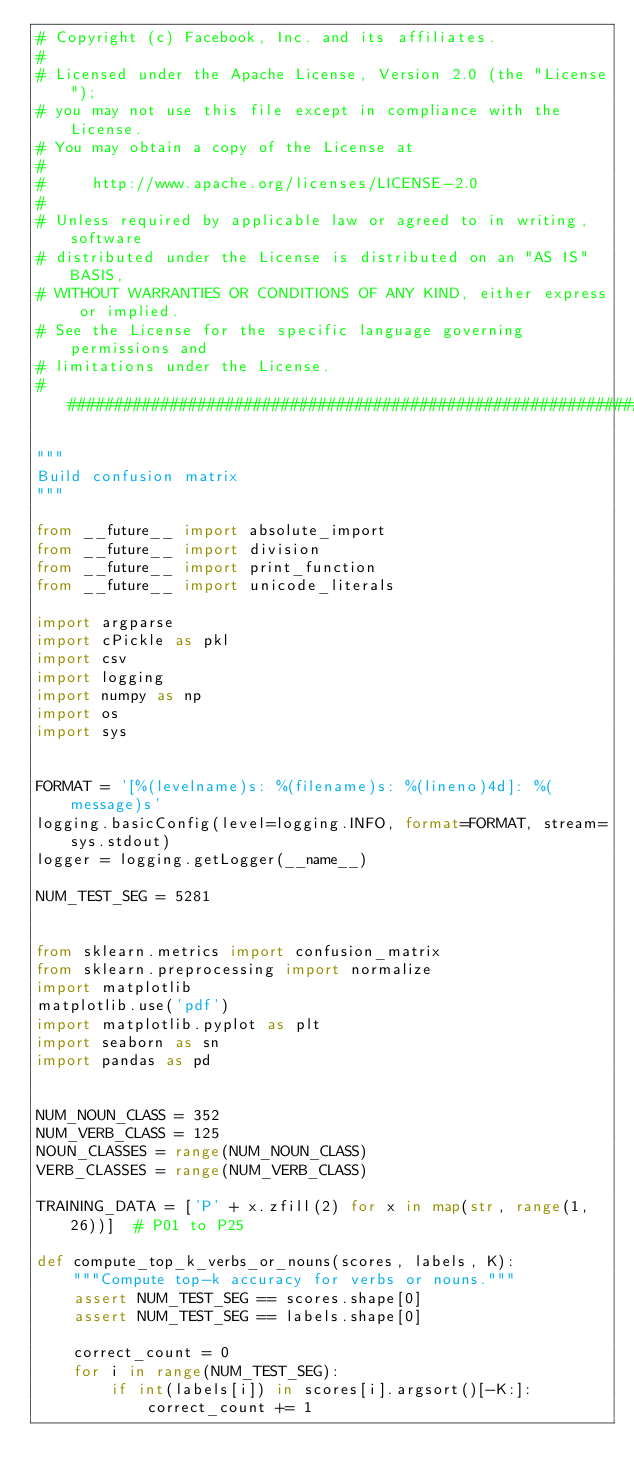<code> <loc_0><loc_0><loc_500><loc_500><_Python_># Copyright (c) Facebook, Inc. and its affiliates.
#
# Licensed under the Apache License, Version 2.0 (the "License");
# you may not use this file except in compliance with the License.
# You may obtain a copy of the License at
#
#     http://www.apache.org/licenses/LICENSE-2.0
#
# Unless required by applicable law or agreed to in writing, software
# distributed under the License is distributed on an "AS IS" BASIS,
# WITHOUT WARRANTIES OR CONDITIONS OF ANY KIND, either express or implied.
# See the License for the specific language governing permissions and
# limitations under the License.
##############################################################################

"""
Build confusion matrix
"""

from __future__ import absolute_import
from __future__ import division
from __future__ import print_function
from __future__ import unicode_literals

import argparse
import cPickle as pkl
import csv
import logging
import numpy as np
import os
import sys


FORMAT = '[%(levelname)s: %(filename)s: %(lineno)4d]: %(message)s'
logging.basicConfig(level=logging.INFO, format=FORMAT, stream=sys.stdout)
logger = logging.getLogger(__name__)

NUM_TEST_SEG = 5281


from sklearn.metrics import confusion_matrix
from sklearn.preprocessing import normalize
import matplotlib
matplotlib.use('pdf')
import matplotlib.pyplot as plt
import seaborn as sn
import pandas as pd


NUM_NOUN_CLASS = 352
NUM_VERB_CLASS = 125
NOUN_CLASSES = range(NUM_NOUN_CLASS)
VERB_CLASSES = range(NUM_VERB_CLASS)

TRAINING_DATA = ['P' + x.zfill(2) for x in map(str, range(1, 26))]  # P01 to P25

def compute_top_k_verbs_or_nouns(scores, labels, K):
    """Compute top-k accuracy for verbs or nouns."""
    assert NUM_TEST_SEG == scores.shape[0]
    assert NUM_TEST_SEG == labels.shape[0]

    correct_count = 0
    for i in range(NUM_TEST_SEG):
        if int(labels[i]) in scores[i].argsort()[-K:]:
            correct_count += 1
</code> 